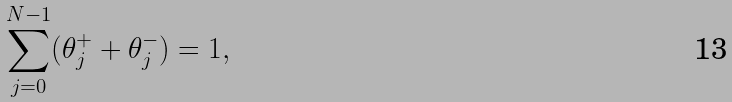Convert formula to latex. <formula><loc_0><loc_0><loc_500><loc_500>\sum _ { j = 0 } ^ { N - 1 } ( \theta _ { j } ^ { + } + \theta _ { j } ^ { - } ) = 1 ,</formula> 